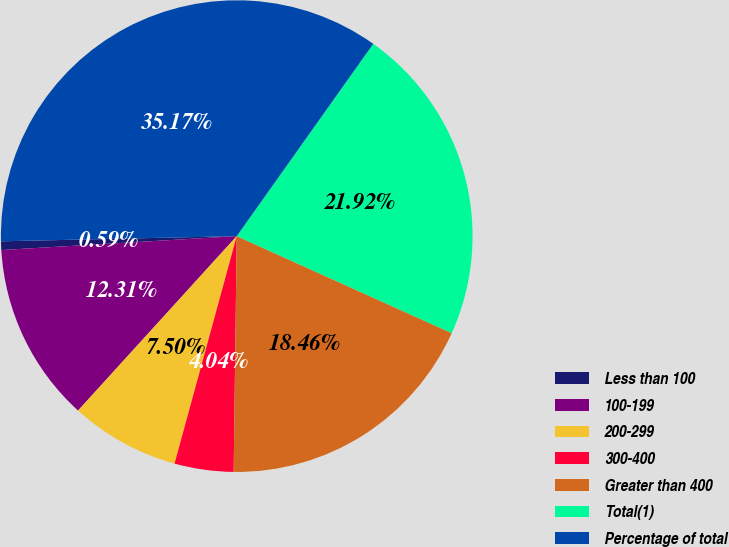Convert chart to OTSL. <chart><loc_0><loc_0><loc_500><loc_500><pie_chart><fcel>Less than 100<fcel>100-199<fcel>200-299<fcel>300-400<fcel>Greater than 400<fcel>Total(1)<fcel>Percentage of total<nl><fcel>0.59%<fcel>12.31%<fcel>7.5%<fcel>4.04%<fcel>18.46%<fcel>21.92%<fcel>35.17%<nl></chart> 